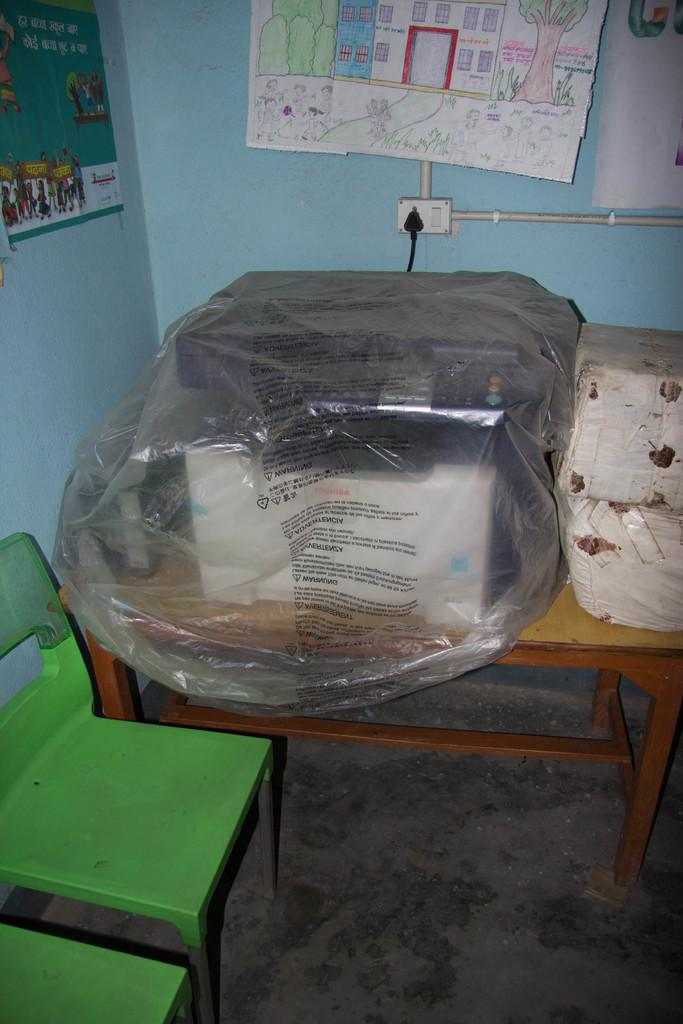What type of structure can be seen in the image? There is a wall in the image. What is covering the wall in the image? There is a sheet in the image. What piece of furniture is present in the image? There is a table in the image. What objects are on the table in the image? There is a box and a television on the table in the image. Where is the switch board located in the image? The switch board is in the image. How many chairs are visible in the image? There are chairs in the image. What type of cherry is sitting on the television in the image? There is no cherry present in the image. What opinion does the box have about the wall in the image? The box is an inanimate object and does not have an opinion. 